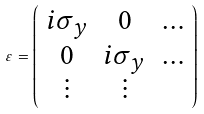<formula> <loc_0><loc_0><loc_500><loc_500>\varepsilon = \left ( \begin{array} { c c c } i \sigma _ { y } & 0 & \dots \\ 0 & i \sigma _ { y } & \dots \\ \vdots & \vdots \end{array} \right )</formula> 